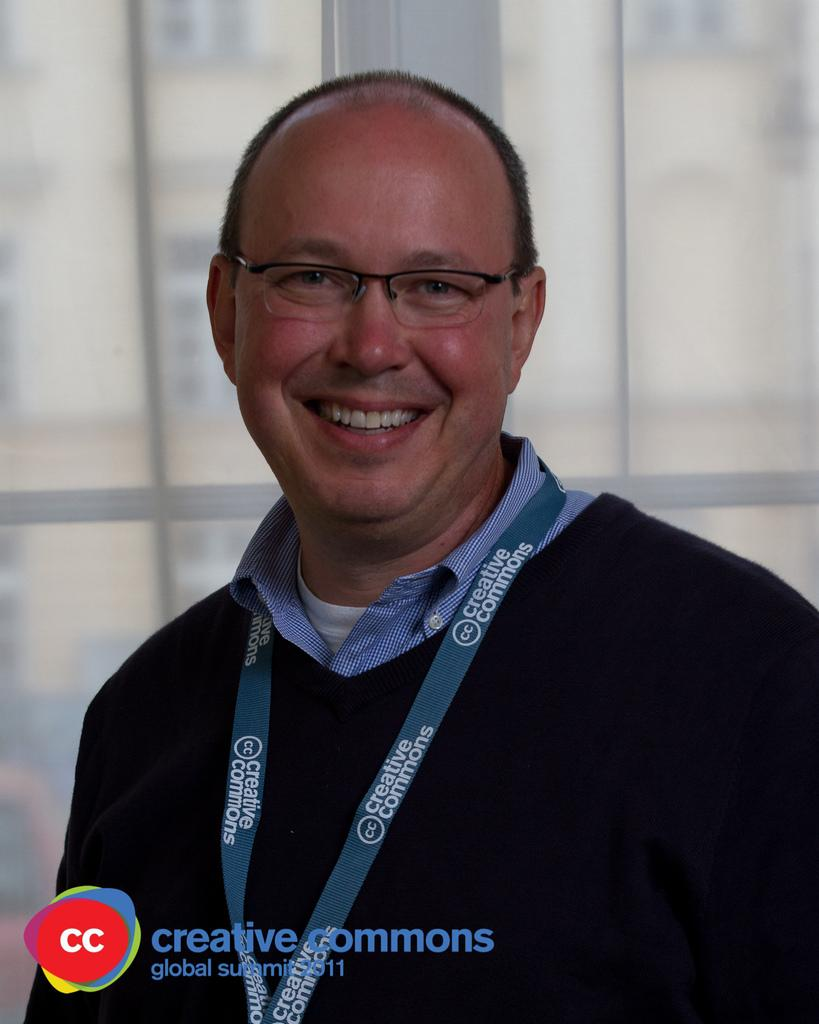What is the main subject of the picture? The main subject of the picture is a man. What is the man doing in the picture? The man is standing in the picture. What is the man's facial expression in the picture? The man is smiling in the picture. What accessories is the man wearing in the picture? The man is wearing spectacles and a coat in the picture. What is the man regretting in the picture? There is no indication in the image that the man is regretting anything. What caused the man to wear spectacles in the picture? The image does not provide information about why the man is wearing spectacles; it only shows that he is wearing them. 